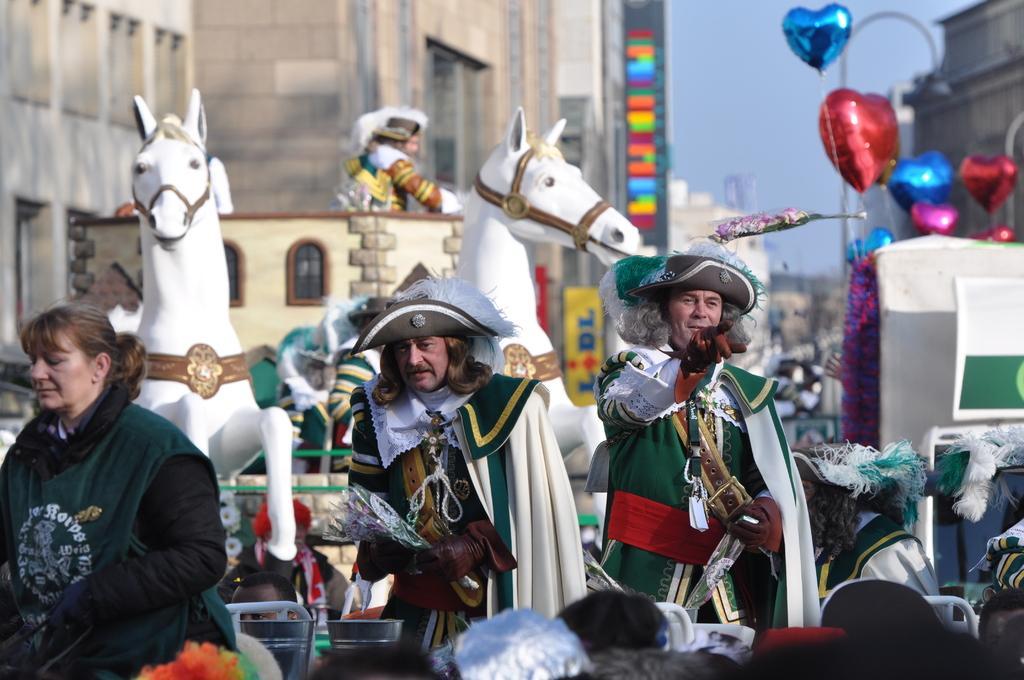Describe this image in one or two sentences. We can see people and we can see balloons and horses. Background we can see buildings and sky. 